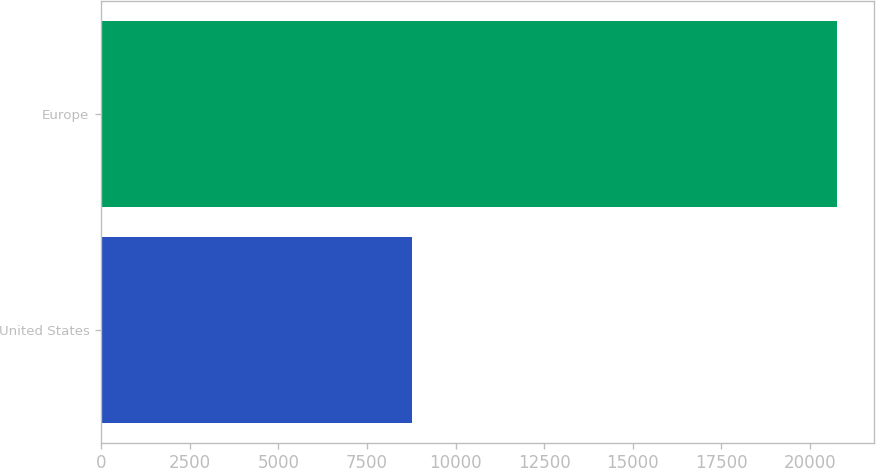<chart> <loc_0><loc_0><loc_500><loc_500><bar_chart><fcel>United States<fcel>Europe<nl><fcel>8772<fcel>20758<nl></chart> 